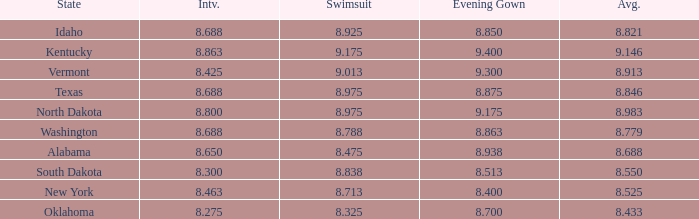What is the average interview score from Kentucky? 8.863. 